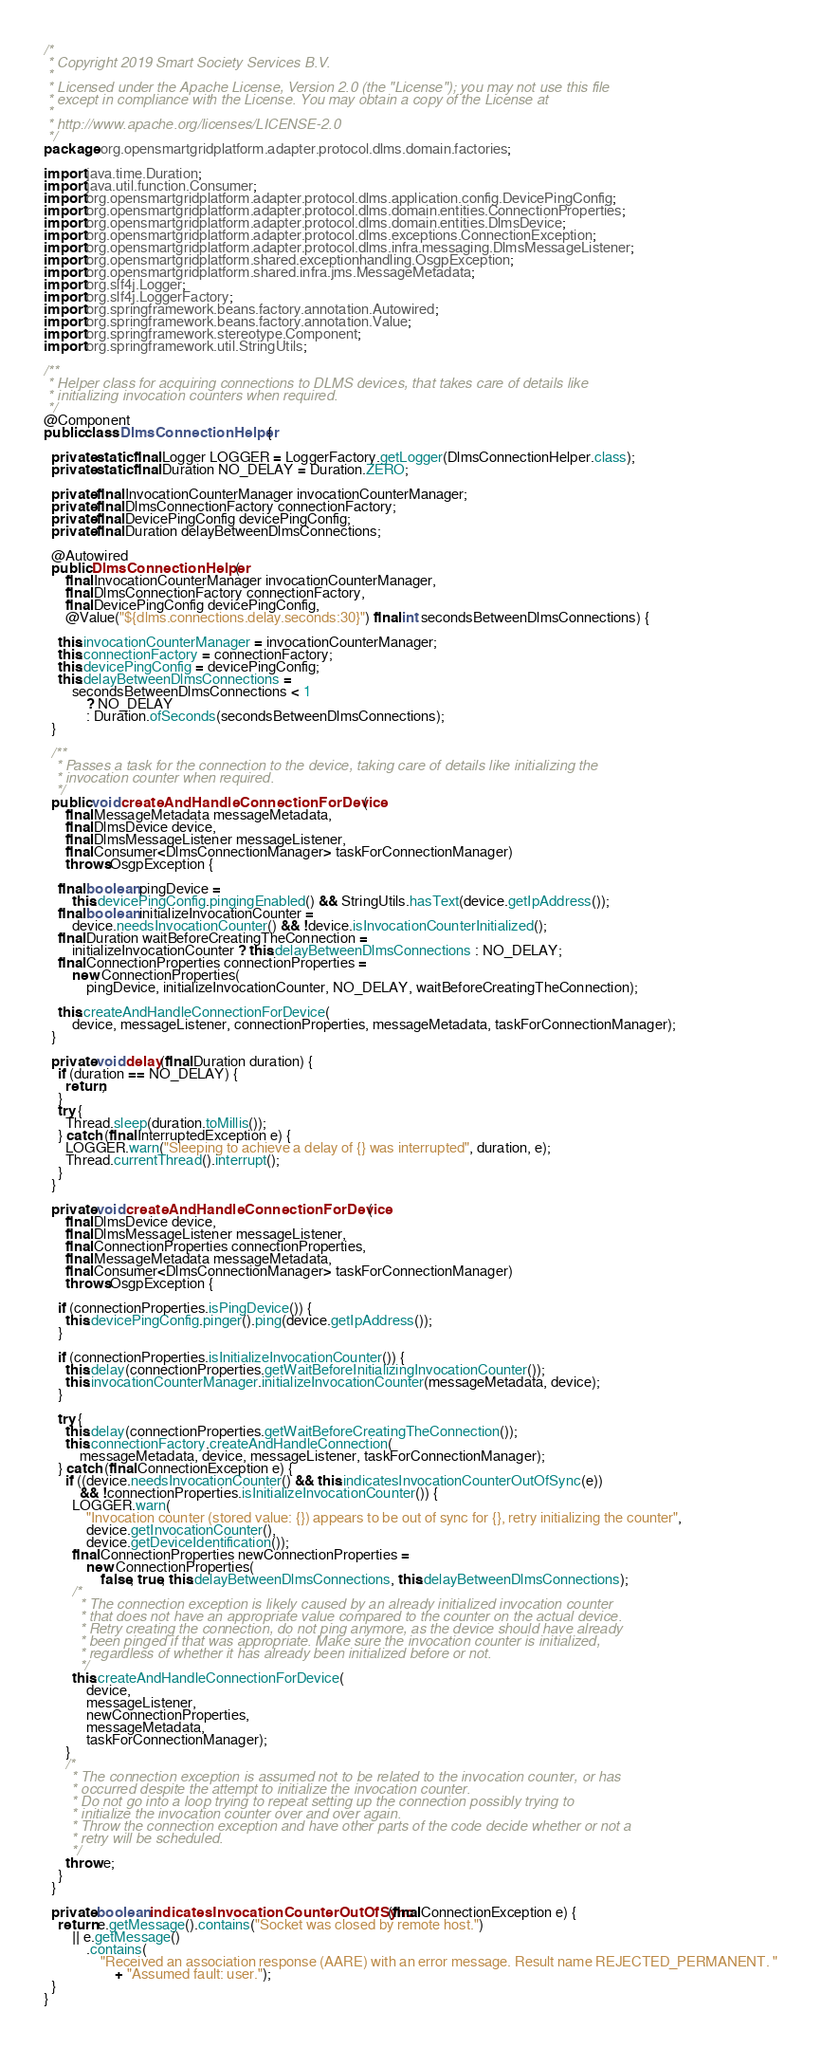Convert code to text. <code><loc_0><loc_0><loc_500><loc_500><_Java_>/*
 * Copyright 2019 Smart Society Services B.V.
 *
 * Licensed under the Apache License, Version 2.0 (the "License"); you may not use this file
 * except in compliance with the License. You may obtain a copy of the License at
 *
 * http://www.apache.org/licenses/LICENSE-2.0
 */
package org.opensmartgridplatform.adapter.protocol.dlms.domain.factories;

import java.time.Duration;
import java.util.function.Consumer;
import org.opensmartgridplatform.adapter.protocol.dlms.application.config.DevicePingConfig;
import org.opensmartgridplatform.adapter.protocol.dlms.domain.entities.ConnectionProperties;
import org.opensmartgridplatform.adapter.protocol.dlms.domain.entities.DlmsDevice;
import org.opensmartgridplatform.adapter.protocol.dlms.exceptions.ConnectionException;
import org.opensmartgridplatform.adapter.protocol.dlms.infra.messaging.DlmsMessageListener;
import org.opensmartgridplatform.shared.exceptionhandling.OsgpException;
import org.opensmartgridplatform.shared.infra.jms.MessageMetadata;
import org.slf4j.Logger;
import org.slf4j.LoggerFactory;
import org.springframework.beans.factory.annotation.Autowired;
import org.springframework.beans.factory.annotation.Value;
import org.springframework.stereotype.Component;
import org.springframework.util.StringUtils;

/**
 * Helper class for acquiring connections to DLMS devices, that takes care of details like
 * initializing invocation counters when required.
 */
@Component
public class DlmsConnectionHelper {

  private static final Logger LOGGER = LoggerFactory.getLogger(DlmsConnectionHelper.class);
  private static final Duration NO_DELAY = Duration.ZERO;

  private final InvocationCounterManager invocationCounterManager;
  private final DlmsConnectionFactory connectionFactory;
  private final DevicePingConfig devicePingConfig;
  private final Duration delayBetweenDlmsConnections;

  @Autowired
  public DlmsConnectionHelper(
      final InvocationCounterManager invocationCounterManager,
      final DlmsConnectionFactory connectionFactory,
      final DevicePingConfig devicePingConfig,
      @Value("${dlms.connections.delay.seconds:30}") final int secondsBetweenDlmsConnections) {

    this.invocationCounterManager = invocationCounterManager;
    this.connectionFactory = connectionFactory;
    this.devicePingConfig = devicePingConfig;
    this.delayBetweenDlmsConnections =
        secondsBetweenDlmsConnections < 1
            ? NO_DELAY
            : Duration.ofSeconds(secondsBetweenDlmsConnections);
  }

  /**
   * Passes a task for the connection to the device, taking care of details like initializing the
   * invocation counter when required.
   */
  public void createAndHandleConnectionForDevice(
      final MessageMetadata messageMetadata,
      final DlmsDevice device,
      final DlmsMessageListener messageListener,
      final Consumer<DlmsConnectionManager> taskForConnectionManager)
      throws OsgpException {

    final boolean pingDevice =
        this.devicePingConfig.pingingEnabled() && StringUtils.hasText(device.getIpAddress());
    final boolean initializeInvocationCounter =
        device.needsInvocationCounter() && !device.isInvocationCounterInitialized();
    final Duration waitBeforeCreatingTheConnection =
        initializeInvocationCounter ? this.delayBetweenDlmsConnections : NO_DELAY;
    final ConnectionProperties connectionProperties =
        new ConnectionProperties(
            pingDevice, initializeInvocationCounter, NO_DELAY, waitBeforeCreatingTheConnection);

    this.createAndHandleConnectionForDevice(
        device, messageListener, connectionProperties, messageMetadata, taskForConnectionManager);
  }

  private void delay(final Duration duration) {
    if (duration == NO_DELAY) {
      return;
    }
    try {
      Thread.sleep(duration.toMillis());
    } catch (final InterruptedException e) {
      LOGGER.warn("Sleeping to achieve a delay of {} was interrupted", duration, e);
      Thread.currentThread().interrupt();
    }
  }

  private void createAndHandleConnectionForDevice(
      final DlmsDevice device,
      final DlmsMessageListener messageListener,
      final ConnectionProperties connectionProperties,
      final MessageMetadata messageMetadata,
      final Consumer<DlmsConnectionManager> taskForConnectionManager)
      throws OsgpException {

    if (connectionProperties.isPingDevice()) {
      this.devicePingConfig.pinger().ping(device.getIpAddress());
    }

    if (connectionProperties.isInitializeInvocationCounter()) {
      this.delay(connectionProperties.getWaitBeforeInitializingInvocationCounter());
      this.invocationCounterManager.initializeInvocationCounter(messageMetadata, device);
    }

    try {
      this.delay(connectionProperties.getWaitBeforeCreatingTheConnection());
      this.connectionFactory.createAndHandleConnection(
          messageMetadata, device, messageListener, taskForConnectionManager);
    } catch (final ConnectionException e) {
      if ((device.needsInvocationCounter() && this.indicatesInvocationCounterOutOfSync(e))
          && !connectionProperties.isInitializeInvocationCounter()) {
        LOGGER.warn(
            "Invocation counter (stored value: {}) appears to be out of sync for {}, retry initializing the counter",
            device.getInvocationCounter(),
            device.getDeviceIdentification());
        final ConnectionProperties newConnectionProperties =
            new ConnectionProperties(
                false, true, this.delayBetweenDlmsConnections, this.delayBetweenDlmsConnections);
        /*
         * The connection exception is likely caused by an already initialized invocation counter
         * that does not have an appropriate value compared to the counter on the actual device.
         * Retry creating the connection, do not ping anymore, as the device should have already
         * been pinged if that was appropriate. Make sure the invocation counter is initialized,
         * regardless of whether it has already been initialized before or not.
         */
        this.createAndHandleConnectionForDevice(
            device,
            messageListener,
            newConnectionProperties,
            messageMetadata,
            taskForConnectionManager);
      }
      /*
       * The connection exception is assumed not to be related to the invocation counter, or has
       * occurred despite the attempt to initialize the invocation counter.
       * Do not go into a loop trying to repeat setting up the connection possibly trying to
       * initialize the invocation counter over and over again.
       * Throw the connection exception and have other parts of the code decide whether or not a
       * retry will be scheduled.
       */
      throw e;
    }
  }

  private boolean indicatesInvocationCounterOutOfSync(final ConnectionException e) {
    return e.getMessage().contains("Socket was closed by remote host.")
        || e.getMessage()
            .contains(
                "Received an association response (AARE) with an error message. Result name REJECTED_PERMANENT. "
                    + "Assumed fault: user.");
  }
}
</code> 